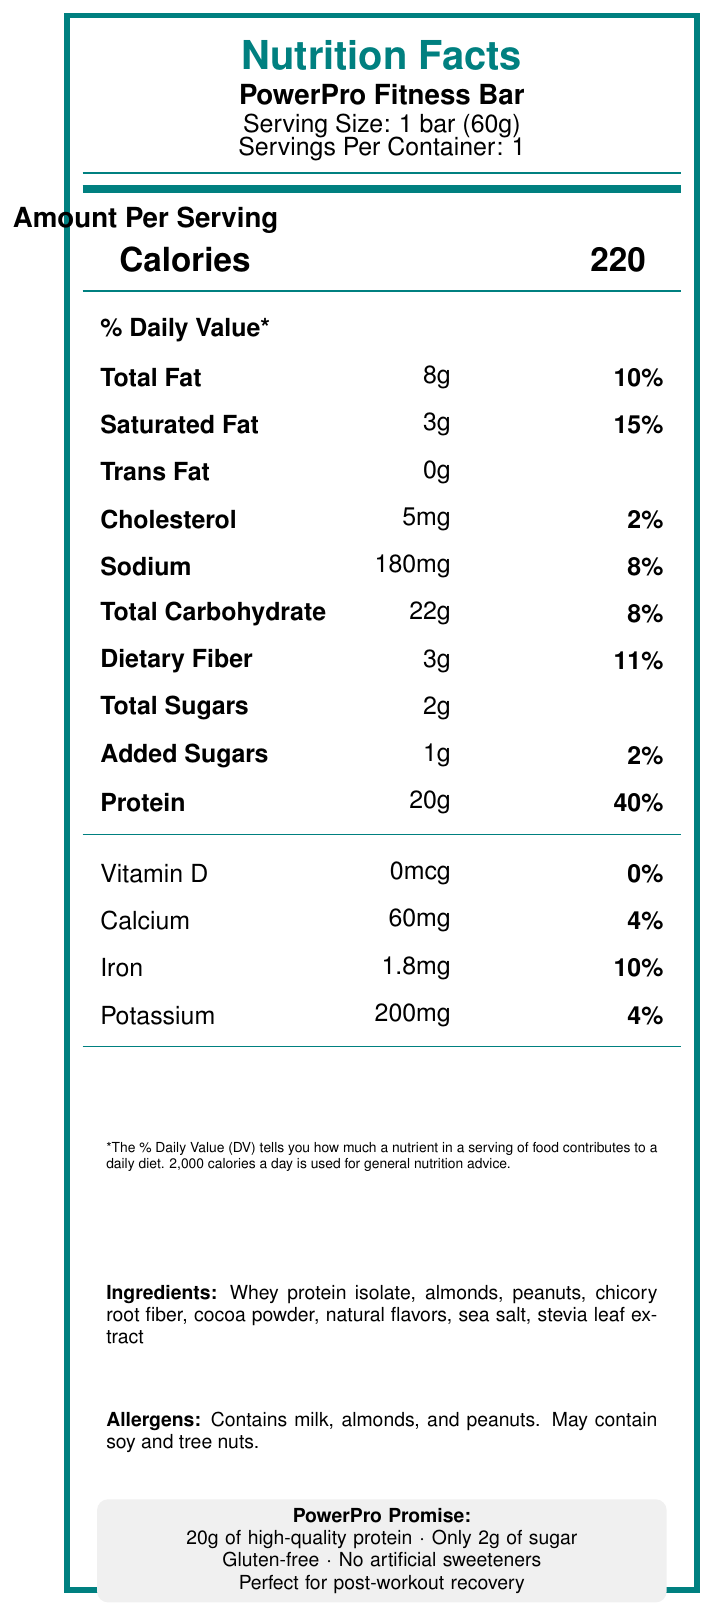what is the serving size of PowerPro Fitness Bar? The document clearly states the serving size as "1 bar (60g)" on the nutrition facts label.
Answer: 1 bar (60g) How many calories are there per serving? The calories per serving are listed as "220" in the Amount Per Serving section.
Answer: 220 What is the protein content per serving in grams? The protein content is mentioned as "20g" in the nutrition facts.
Answer: 20g Is the PowerPro Fitness Bar gluten-free? The marketing claims section states that the PowerPro Fitness Bar is "Gluten-free."
Answer: Yes What are the main ingredients in the PowerPro Fitness Bar? The ingredients section lists these as the main ingredients.
Answer: Whey protein isolate, almonds, peanuts, chicory root fiber, cocoa powder, natural flavors, sea salt, stevia leaf extract Which of the following makes up 15% of the daily value? A. Total Fat B. Saturated Fat C. Sodium D. Dietary Fiber Saturated Fat is listed as having 15% of the daily value in the nutrition facts.
Answer: B What is the total carbohydrate content per serving? The total carbohydrate content per serving is mentioned as "22g."
Answer: 22g How much added sugar is in the PowerPro Fitness Bar? The label shows that there is "1g" of added sugar per serving.
Answer: 1g Is there any trans fat in the PowerPro Fitness Bar? The document shows "Trans Fat 0g," indicating it contains no trans fat.
Answer: No Which of the following allergens are contained in the PowerPro Fitness Bar? A. Soy B. Milk C. Wheat D. Eggs The allergens section states that the bar contains milk, almonds, and peanuts but no mention of soy, wheat, or eggs.
Answer: B Summarize the main nutritional claims of the PowerPro Fitness Bar. The marketing claims highlight these main points regarding the product's nutritional benefits and features.
Answer: 20g of high-quality protein, only 2g of sugar, gluten-free, no artificial sweeteners, perfect for post-workout recovery What is the percent daily value of Sodium? The label indicates that the sodium content is 180mg, which is 8% of the daily value.
Answer: 8% How much Vitamin D does the PowerPro Fitness Bar provide? The label specifies that the Vitamin D content is 0mcg.
Answer: 0mcg What kind of fiber is used in the PowerPro Fitness Bar? Chicory root fiber is listed as one of the ingredients on the label.
Answer: Chicory root fiber Can the exact protein source be determined? The ingredient list specifies "Whey protein isolate" as the protein source.
Answer: Yes What are the strategies listed for email marketing of the PowerPro Fitness Bar? These tips are found within the email marketing tips section in the document.
Answer: Segment fitness enthusiast subscribers, create personalized campaigns, use A/B testing, include customer testimonials, offer exclusive discounts Describe the allergen warning provided on the package. The allergens section provides this information about potential allergenic ingredients.
Answer: The bar contains milk, almonds, and peanuts, and may contain soy and tree nuts. How much cholesterol is in the PowerPro Fitness Bar? The cholesterol content is indicated as "5mg" per serving on the label.
Answer: 5mg What is the calcium content in milligrams? The label lists "Calcium 60mg" under the vitamins and minerals section.
Answer: 60mg Can we determine the manufacturing date of the PowerPro Fitness Bar from this document? The document does not provide any details regarding the manufacturing date of the bar.
Answer: Not enough information 